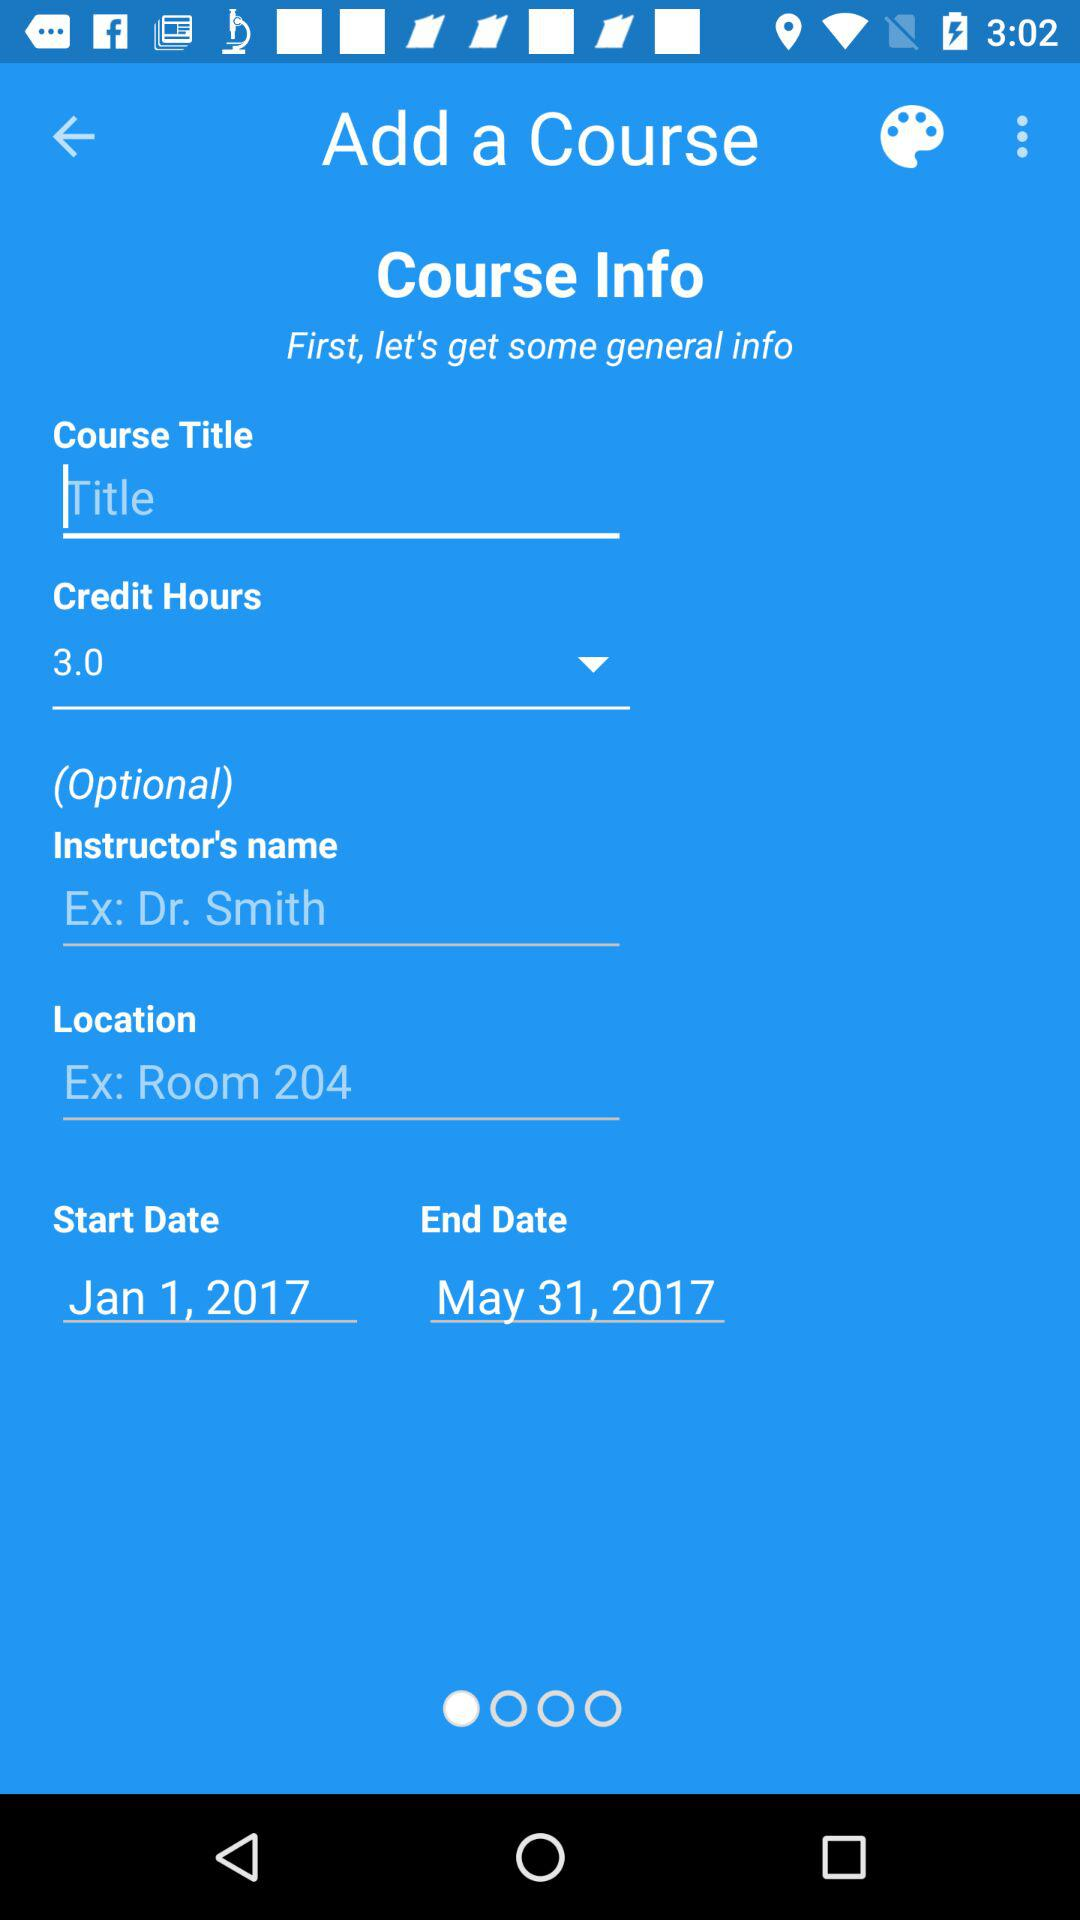What is the course's end date? The course's end date is May 31, 2017. 